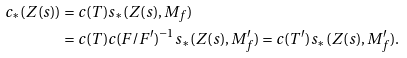<formula> <loc_0><loc_0><loc_500><loc_500>c _ { * } ( Z ( s ) ) & = c ( T ) s _ { * } ( Z ( s ) , M _ { f } ) \\ & = c ( T ) c ( F / F ^ { \prime } ) ^ { - 1 } s _ { * } ( Z ( s ) , M ^ { \prime } _ { f } ) = c ( T ^ { \prime } ) s _ { * } ( Z ( s ) , M ^ { \prime } _ { f } ) .</formula> 